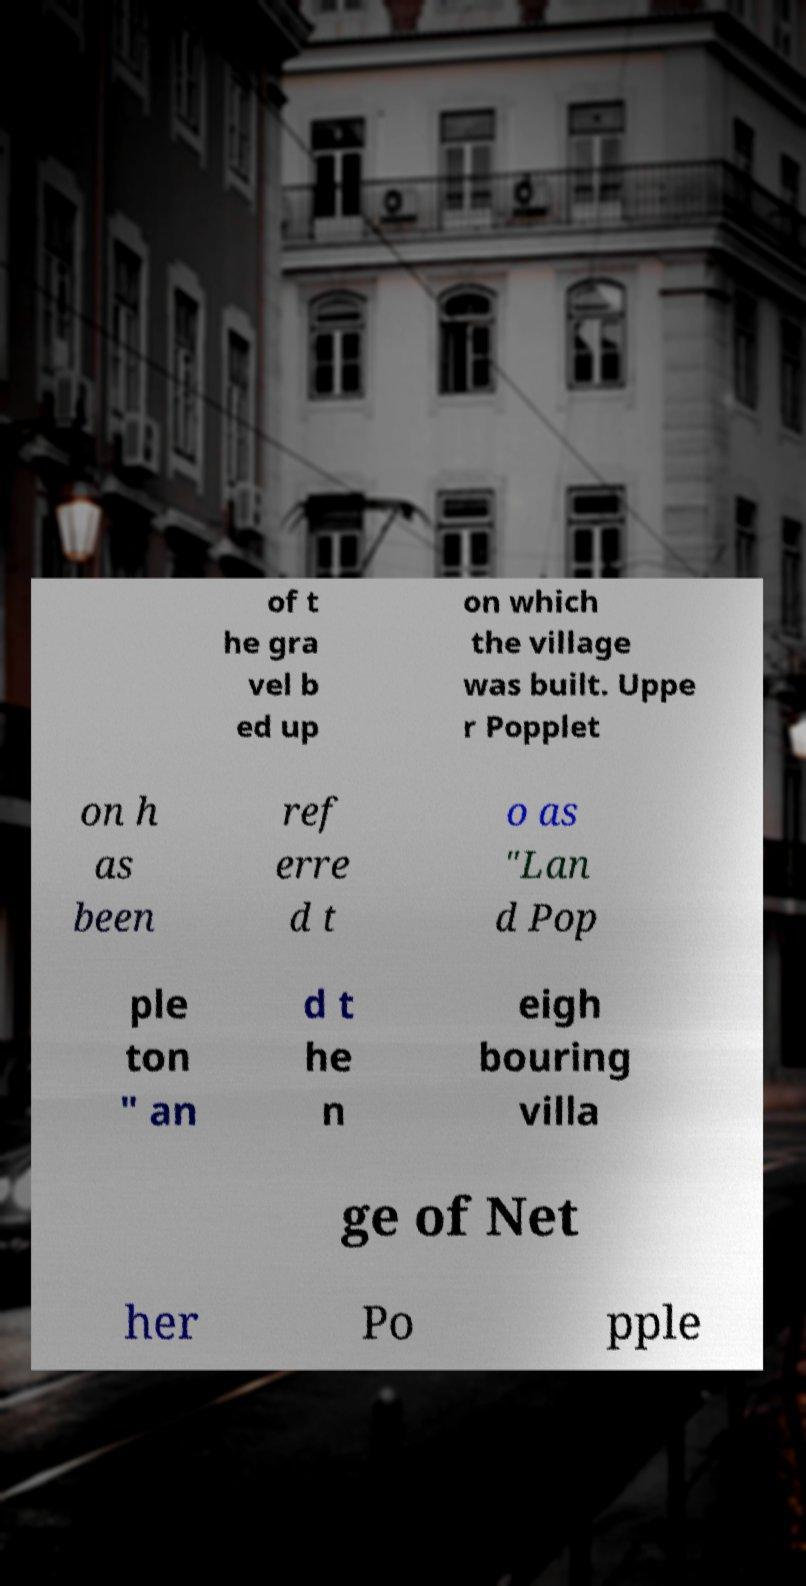Please identify and transcribe the text found in this image. of t he gra vel b ed up on which the village was built. Uppe r Popplet on h as been ref erre d t o as "Lan d Pop ple ton " an d t he n eigh bouring villa ge of Net her Po pple 